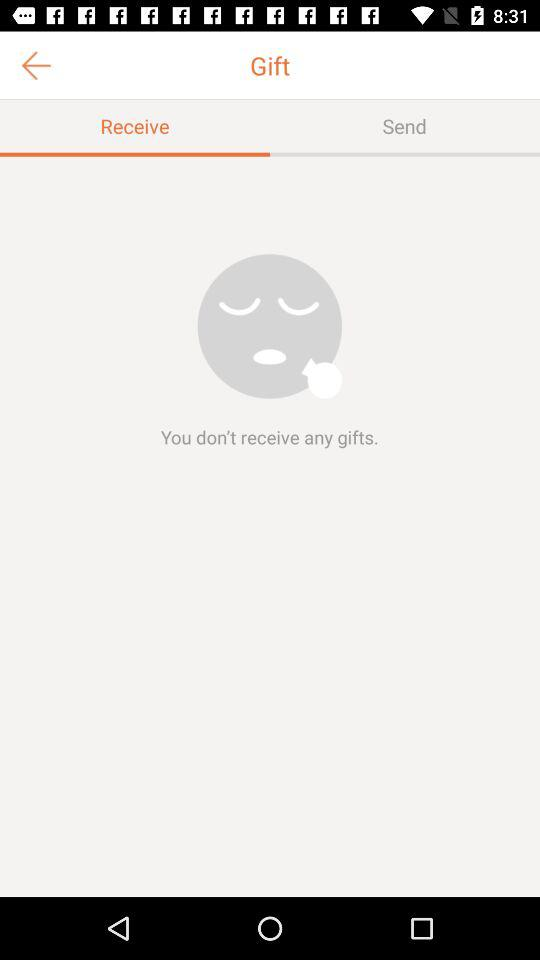Are there any gifts received? You don't receive any gifts. 